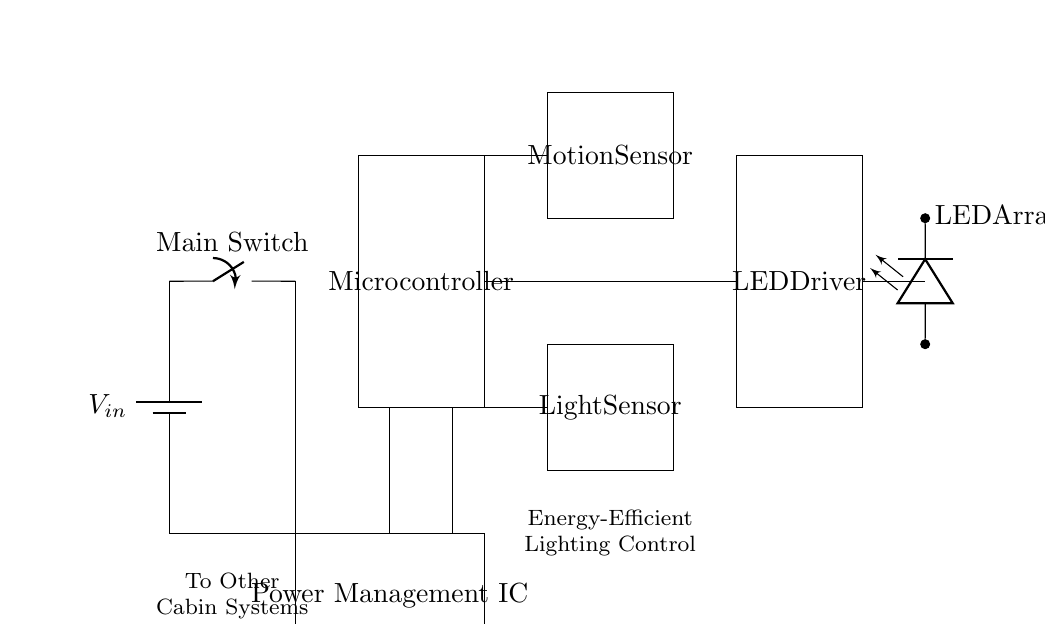What is the role of the microcontroller in this circuit? The microcontroller processes signals from the motion and light sensors, controlling the LED driver based on detected conditions.
Answer: Control lighting What connects the main switch to the power management IC? The main switch is connected directly to the power management IC, allowing for the control of power supply to the circuit.
Answer: Direct connection Which components are associated with energy-efficient lighting control? The motion sensor, light sensor, LED driver, and microcontroller work together to ensure energy-efficient operation by adjusting lighting based on occupancy and ambient light.
Answer: All mentioned components How many sensors are in the circuit? There are two sensors: the motion sensor and the light sensor, each serving a unique purpose in enhancing energy efficiency.
Answer: Two What is the output of the LED driver in the circuit? The output of the LED driver feeds into the LED array, which provides the actual lighting in the guest cabins based on the driver’s control signals.
Answer: LED array Which component is responsible for detecting absence or presence of cabin guests? The motion sensor is responsible for detecting the presence or absence of guests by sensing movement in the cabin area.
Answer: Motion sensor 